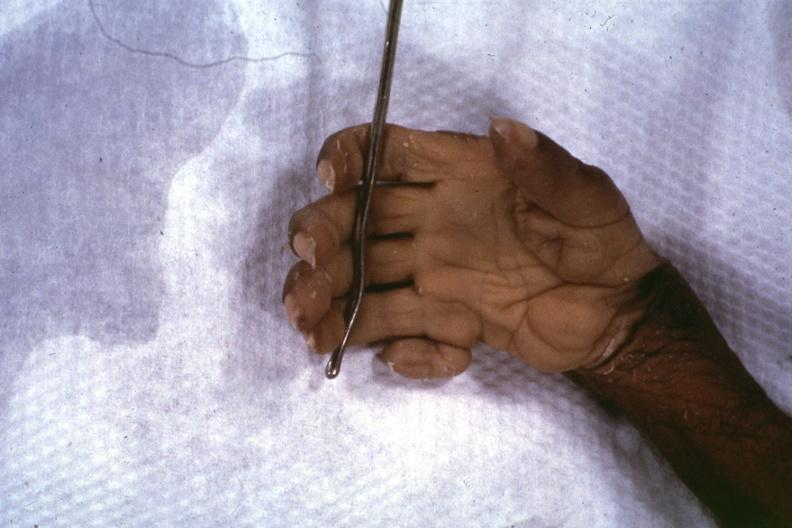re skin over back a buttocks present?
Answer the question using a single word or phrase. Yes 